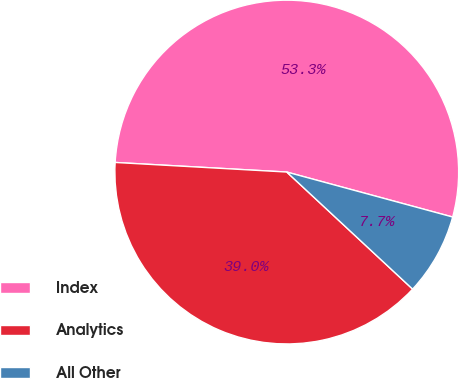<chart> <loc_0><loc_0><loc_500><loc_500><pie_chart><fcel>Index<fcel>Analytics<fcel>All Other<nl><fcel>53.32%<fcel>38.96%<fcel>7.71%<nl></chart> 